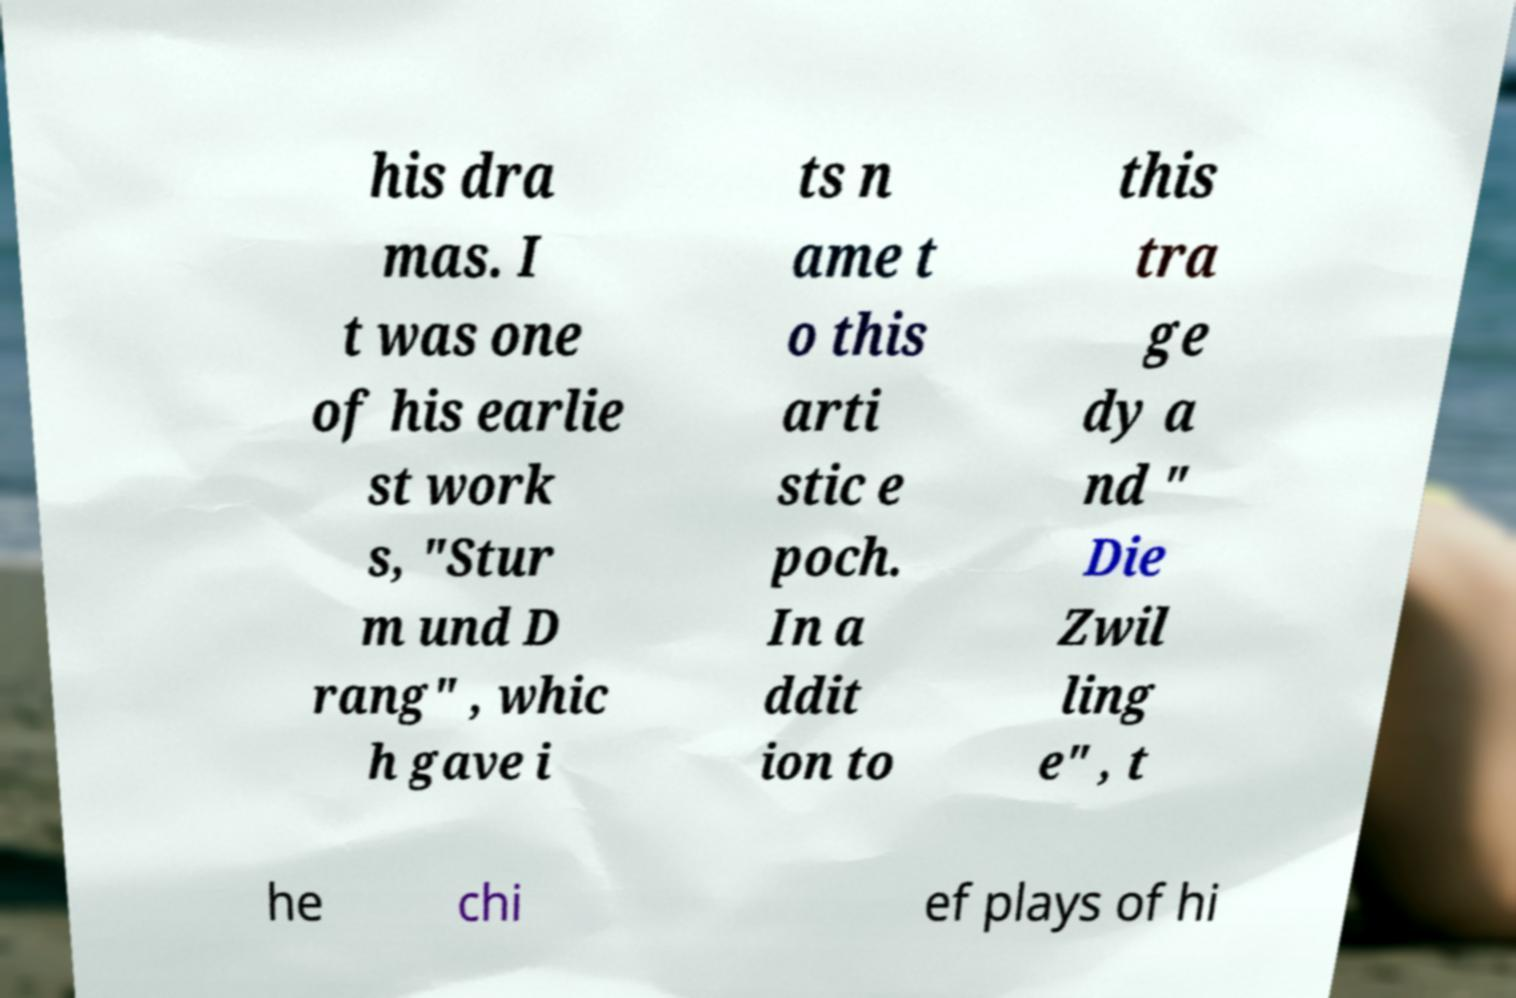There's text embedded in this image that I need extracted. Can you transcribe it verbatim? his dra mas. I t was one of his earlie st work s, "Stur m und D rang" , whic h gave i ts n ame t o this arti stic e poch. In a ddit ion to this tra ge dy a nd " Die Zwil ling e" , t he chi ef plays of hi 